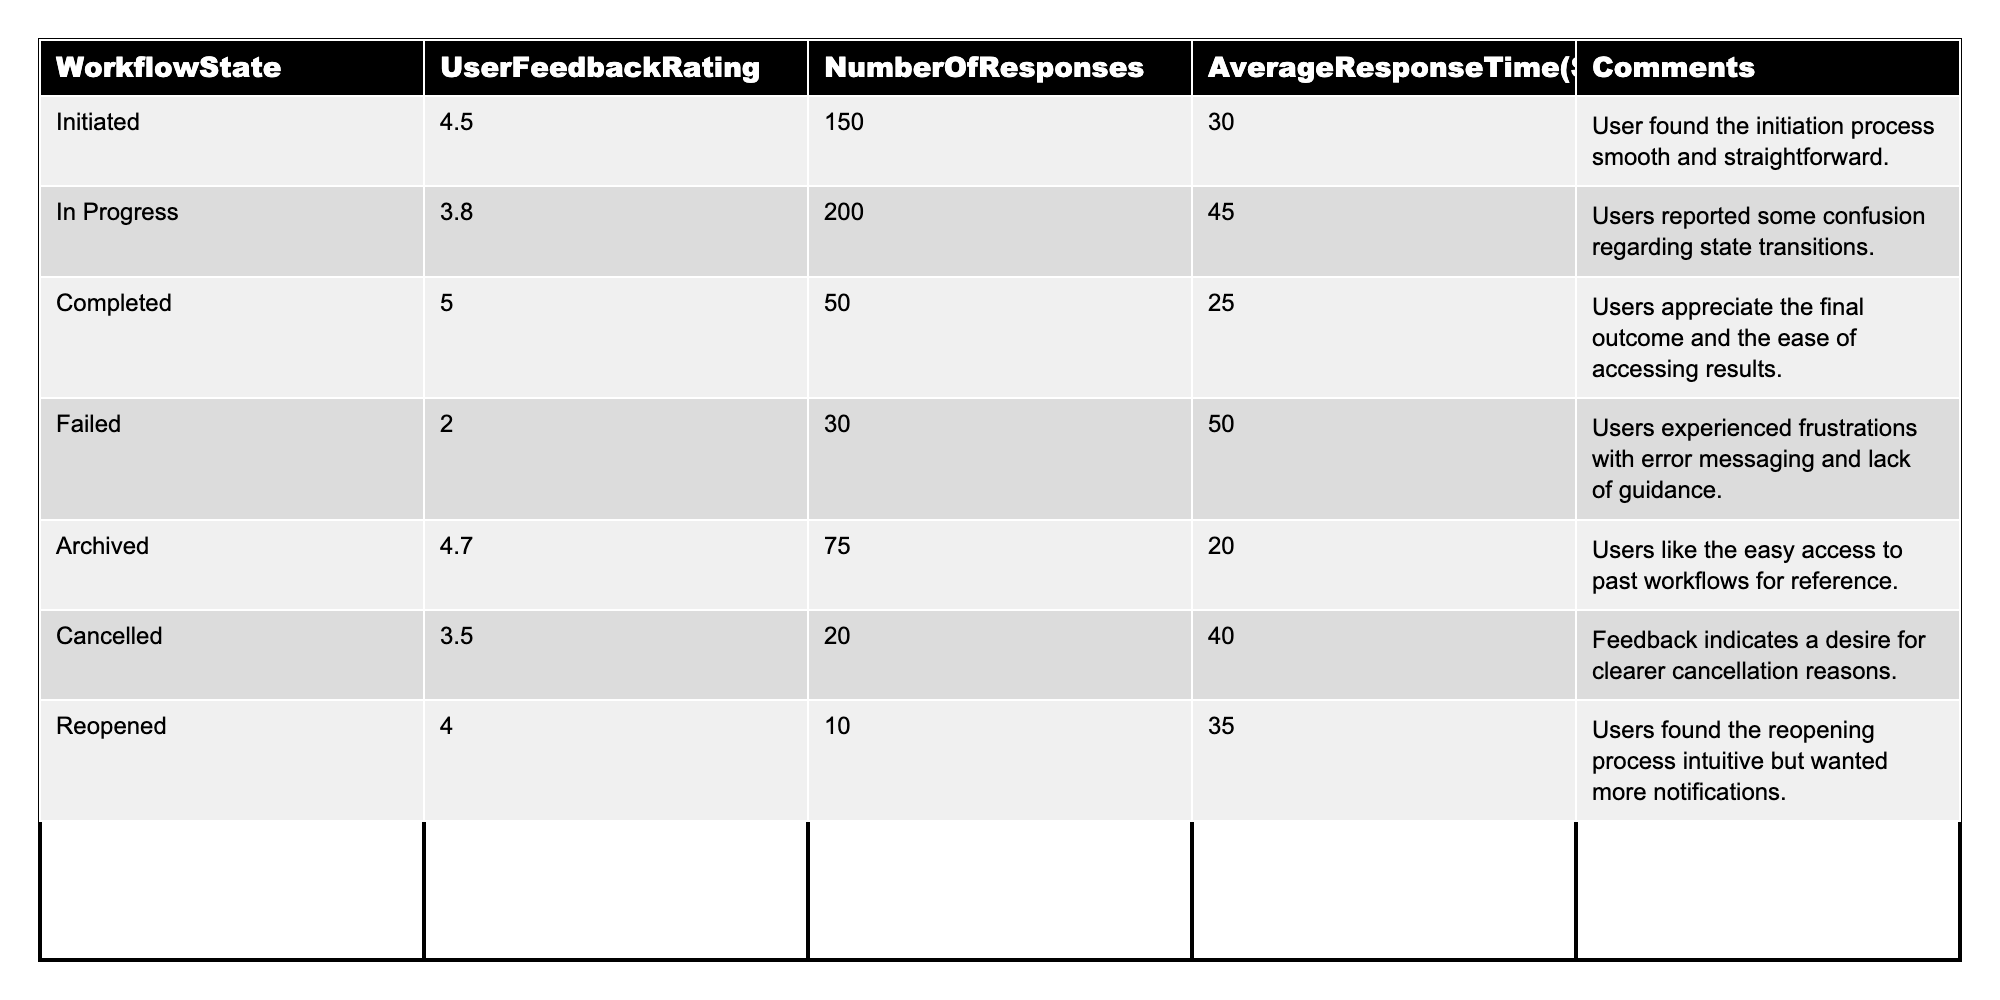What is the User Feedback Rating for the Completed state? The table shows the User Feedback Rating for each workflow state. For the Completed state, the rating is directly listed as 5.0.
Answer: 5.0 Which workflow state has the highest User Feedback Rating? By inspecting the ratings in the table, we see the Completed state has a rating of 5.0, which is the highest among all states.
Answer: Completed How many responses were received for the In Progress state? Looking at the table, the Number of Responses for the In Progress state is given as 200.
Answer: 200 What is the Average Response Time for the Failed state? The table lists the Average Response Time for the Failed state as 50 seconds.
Answer: 50 seconds Is the User Feedback Rating for Archived higher than for Cancelled? The Archived rating is 4.7 and the Cancelled rating is 3.5. Since 4.7 is greater than 3.5, the statement is true.
Answer: Yes What is the total number of responses for states with a User Feedback Rating above 4.0? The states with ratings above 4.0 are Initiated (150), Completed (50), and Archived (75). Adding these gives 150 + 50 + 75 = 275.
Answer: 275 What is the average User Feedback Rating for the states that were cancelled or failed? The Cancelled rating is 3.5 and the Failed rating is 2.0. Adding these gives 3.5 + 2.0 = 5.5. Dividing by the number of states (2) gives an average of 5.5 / 2 = 2.75.
Answer: 2.75 Which state had the lowest User Feedback Rating, and what was it? The table indicates the Failed state had the lowest rating of 2.0.
Answer: Failed, 2.0 Calculate the difference in Average Response Time between the Completed state and the Failed state. The Average Response Time for Completed is 25 seconds and for Failed is 50 seconds. The difference is 50 - 25 = 25 seconds.
Answer: 25 seconds Are there more responses for the In Progress state than for the Cancelled state combined with the Reopened state? The In Progress state has 200 responses, the Cancelled state has 20, and the Reopened state has 10, totaling 20 + 10 = 30 for the latter two. Since 200 is greater than 30, the statement is true.
Answer: Yes 